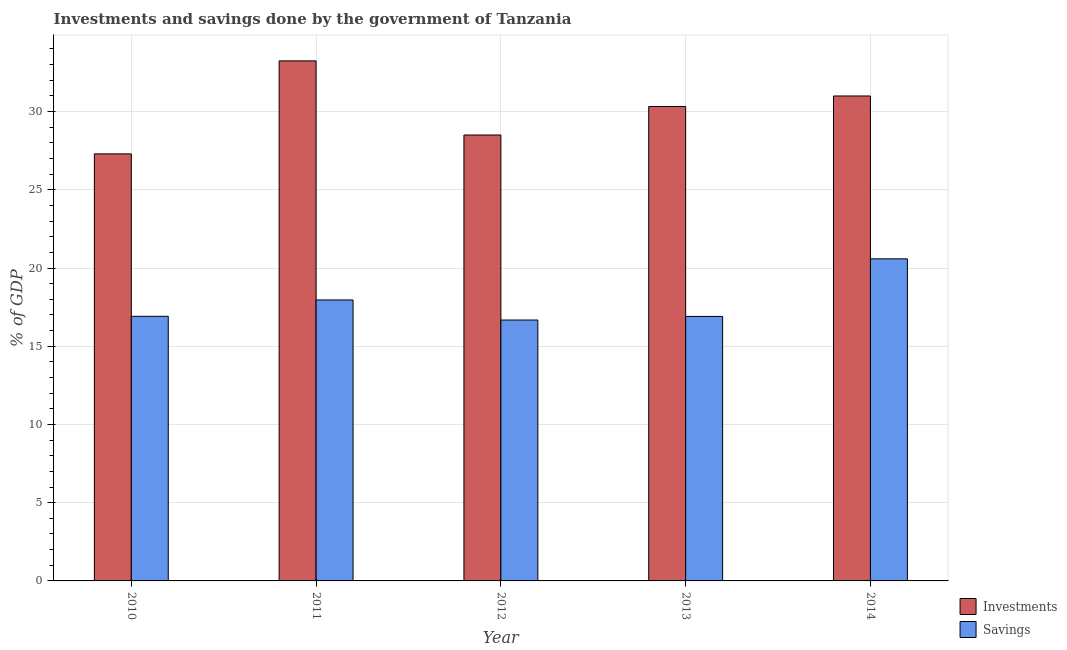Are the number of bars per tick equal to the number of legend labels?
Provide a succinct answer. Yes. Are the number of bars on each tick of the X-axis equal?
Provide a short and direct response. Yes. How many bars are there on the 3rd tick from the right?
Provide a succinct answer. 2. What is the savings of government in 2013?
Offer a very short reply. 16.91. Across all years, what is the maximum investments of government?
Offer a very short reply. 33.24. Across all years, what is the minimum investments of government?
Make the answer very short. 27.3. In which year was the savings of government maximum?
Give a very brief answer. 2014. In which year was the savings of government minimum?
Provide a short and direct response. 2012. What is the total investments of government in the graph?
Ensure brevity in your answer.  150.36. What is the difference between the savings of government in 2012 and that in 2014?
Provide a succinct answer. -3.91. What is the difference between the investments of government in 2010 and the savings of government in 2014?
Keep it short and to the point. -3.7. What is the average investments of government per year?
Provide a succinct answer. 30.07. In the year 2013, what is the difference between the savings of government and investments of government?
Provide a short and direct response. 0. In how many years, is the savings of government greater than 10 %?
Your answer should be compact. 5. What is the ratio of the investments of government in 2010 to that in 2012?
Ensure brevity in your answer.  0.96. Is the difference between the investments of government in 2012 and 2014 greater than the difference between the savings of government in 2012 and 2014?
Provide a succinct answer. No. What is the difference between the highest and the second highest investments of government?
Your response must be concise. 2.24. What is the difference between the highest and the lowest investments of government?
Your response must be concise. 5.94. In how many years, is the investments of government greater than the average investments of government taken over all years?
Your answer should be very brief. 3. Is the sum of the investments of government in 2010 and 2014 greater than the maximum savings of government across all years?
Ensure brevity in your answer.  Yes. What does the 2nd bar from the left in 2011 represents?
Your response must be concise. Savings. What does the 1st bar from the right in 2013 represents?
Ensure brevity in your answer.  Savings. Are all the bars in the graph horizontal?
Provide a short and direct response. No. What is the difference between two consecutive major ticks on the Y-axis?
Offer a terse response. 5. Are the values on the major ticks of Y-axis written in scientific E-notation?
Provide a succinct answer. No. Does the graph contain grids?
Ensure brevity in your answer.  Yes. Where does the legend appear in the graph?
Your response must be concise. Bottom right. What is the title of the graph?
Offer a very short reply. Investments and savings done by the government of Tanzania. What is the label or title of the Y-axis?
Your response must be concise. % of GDP. What is the % of GDP of Investments in 2010?
Offer a terse response. 27.3. What is the % of GDP in Savings in 2010?
Your response must be concise. 16.91. What is the % of GDP in Investments in 2011?
Give a very brief answer. 33.24. What is the % of GDP of Savings in 2011?
Your answer should be compact. 17.96. What is the % of GDP of Investments in 2012?
Provide a short and direct response. 28.5. What is the % of GDP of Savings in 2012?
Your answer should be compact. 16.68. What is the % of GDP in Investments in 2013?
Your answer should be very brief. 30.32. What is the % of GDP in Savings in 2013?
Make the answer very short. 16.91. What is the % of GDP of Investments in 2014?
Give a very brief answer. 31. What is the % of GDP of Savings in 2014?
Provide a succinct answer. 20.59. Across all years, what is the maximum % of GDP in Investments?
Offer a very short reply. 33.24. Across all years, what is the maximum % of GDP in Savings?
Provide a succinct answer. 20.59. Across all years, what is the minimum % of GDP in Investments?
Offer a very short reply. 27.3. Across all years, what is the minimum % of GDP of Savings?
Offer a terse response. 16.68. What is the total % of GDP in Investments in the graph?
Offer a very short reply. 150.36. What is the total % of GDP of Savings in the graph?
Offer a terse response. 89.04. What is the difference between the % of GDP in Investments in 2010 and that in 2011?
Ensure brevity in your answer.  -5.94. What is the difference between the % of GDP of Savings in 2010 and that in 2011?
Provide a succinct answer. -1.05. What is the difference between the % of GDP in Investments in 2010 and that in 2012?
Offer a very short reply. -1.21. What is the difference between the % of GDP in Savings in 2010 and that in 2012?
Offer a terse response. 0.24. What is the difference between the % of GDP in Investments in 2010 and that in 2013?
Provide a short and direct response. -3.03. What is the difference between the % of GDP of Savings in 2010 and that in 2013?
Keep it short and to the point. 0.01. What is the difference between the % of GDP of Investments in 2010 and that in 2014?
Give a very brief answer. -3.7. What is the difference between the % of GDP in Savings in 2010 and that in 2014?
Keep it short and to the point. -3.67. What is the difference between the % of GDP of Investments in 2011 and that in 2012?
Offer a terse response. 4.74. What is the difference between the % of GDP of Savings in 2011 and that in 2012?
Give a very brief answer. 1.28. What is the difference between the % of GDP in Investments in 2011 and that in 2013?
Make the answer very short. 2.92. What is the difference between the % of GDP of Savings in 2011 and that in 2013?
Ensure brevity in your answer.  1.05. What is the difference between the % of GDP of Investments in 2011 and that in 2014?
Make the answer very short. 2.24. What is the difference between the % of GDP in Savings in 2011 and that in 2014?
Keep it short and to the point. -2.63. What is the difference between the % of GDP of Investments in 2012 and that in 2013?
Your answer should be very brief. -1.82. What is the difference between the % of GDP in Savings in 2012 and that in 2013?
Provide a short and direct response. -0.23. What is the difference between the % of GDP in Investments in 2012 and that in 2014?
Your answer should be very brief. -2.49. What is the difference between the % of GDP in Savings in 2012 and that in 2014?
Offer a very short reply. -3.91. What is the difference between the % of GDP of Investments in 2013 and that in 2014?
Make the answer very short. -0.67. What is the difference between the % of GDP of Savings in 2013 and that in 2014?
Provide a short and direct response. -3.68. What is the difference between the % of GDP in Investments in 2010 and the % of GDP in Savings in 2011?
Your response must be concise. 9.34. What is the difference between the % of GDP in Investments in 2010 and the % of GDP in Savings in 2012?
Offer a terse response. 10.62. What is the difference between the % of GDP in Investments in 2010 and the % of GDP in Savings in 2013?
Your response must be concise. 10.39. What is the difference between the % of GDP in Investments in 2010 and the % of GDP in Savings in 2014?
Offer a terse response. 6.71. What is the difference between the % of GDP in Investments in 2011 and the % of GDP in Savings in 2012?
Your answer should be compact. 16.56. What is the difference between the % of GDP in Investments in 2011 and the % of GDP in Savings in 2013?
Keep it short and to the point. 16.33. What is the difference between the % of GDP in Investments in 2011 and the % of GDP in Savings in 2014?
Keep it short and to the point. 12.65. What is the difference between the % of GDP of Investments in 2012 and the % of GDP of Savings in 2013?
Ensure brevity in your answer.  11.6. What is the difference between the % of GDP of Investments in 2012 and the % of GDP of Savings in 2014?
Provide a succinct answer. 7.92. What is the difference between the % of GDP of Investments in 2013 and the % of GDP of Savings in 2014?
Offer a very short reply. 9.74. What is the average % of GDP of Investments per year?
Ensure brevity in your answer.  30.07. What is the average % of GDP in Savings per year?
Your answer should be very brief. 17.81. In the year 2010, what is the difference between the % of GDP in Investments and % of GDP in Savings?
Ensure brevity in your answer.  10.38. In the year 2011, what is the difference between the % of GDP of Investments and % of GDP of Savings?
Offer a terse response. 15.28. In the year 2012, what is the difference between the % of GDP in Investments and % of GDP in Savings?
Ensure brevity in your answer.  11.83. In the year 2013, what is the difference between the % of GDP in Investments and % of GDP in Savings?
Your answer should be very brief. 13.42. In the year 2014, what is the difference between the % of GDP of Investments and % of GDP of Savings?
Your answer should be very brief. 10.41. What is the ratio of the % of GDP in Investments in 2010 to that in 2011?
Your answer should be compact. 0.82. What is the ratio of the % of GDP in Savings in 2010 to that in 2011?
Provide a succinct answer. 0.94. What is the ratio of the % of GDP of Investments in 2010 to that in 2012?
Keep it short and to the point. 0.96. What is the ratio of the % of GDP in Savings in 2010 to that in 2012?
Your answer should be very brief. 1.01. What is the ratio of the % of GDP in Investments in 2010 to that in 2013?
Your response must be concise. 0.9. What is the ratio of the % of GDP in Savings in 2010 to that in 2013?
Provide a succinct answer. 1. What is the ratio of the % of GDP of Investments in 2010 to that in 2014?
Ensure brevity in your answer.  0.88. What is the ratio of the % of GDP of Savings in 2010 to that in 2014?
Offer a very short reply. 0.82. What is the ratio of the % of GDP of Investments in 2011 to that in 2012?
Offer a very short reply. 1.17. What is the ratio of the % of GDP in Savings in 2011 to that in 2012?
Provide a succinct answer. 1.08. What is the ratio of the % of GDP in Investments in 2011 to that in 2013?
Offer a very short reply. 1.1. What is the ratio of the % of GDP of Savings in 2011 to that in 2013?
Make the answer very short. 1.06. What is the ratio of the % of GDP of Investments in 2011 to that in 2014?
Ensure brevity in your answer.  1.07. What is the ratio of the % of GDP in Savings in 2011 to that in 2014?
Provide a short and direct response. 0.87. What is the ratio of the % of GDP in Investments in 2012 to that in 2013?
Your answer should be very brief. 0.94. What is the ratio of the % of GDP of Savings in 2012 to that in 2013?
Offer a terse response. 0.99. What is the ratio of the % of GDP in Investments in 2012 to that in 2014?
Provide a succinct answer. 0.92. What is the ratio of the % of GDP of Savings in 2012 to that in 2014?
Your answer should be compact. 0.81. What is the ratio of the % of GDP in Investments in 2013 to that in 2014?
Offer a terse response. 0.98. What is the ratio of the % of GDP of Savings in 2013 to that in 2014?
Keep it short and to the point. 0.82. What is the difference between the highest and the second highest % of GDP in Investments?
Your answer should be compact. 2.24. What is the difference between the highest and the second highest % of GDP in Savings?
Keep it short and to the point. 2.63. What is the difference between the highest and the lowest % of GDP in Investments?
Provide a short and direct response. 5.94. What is the difference between the highest and the lowest % of GDP of Savings?
Your answer should be compact. 3.91. 